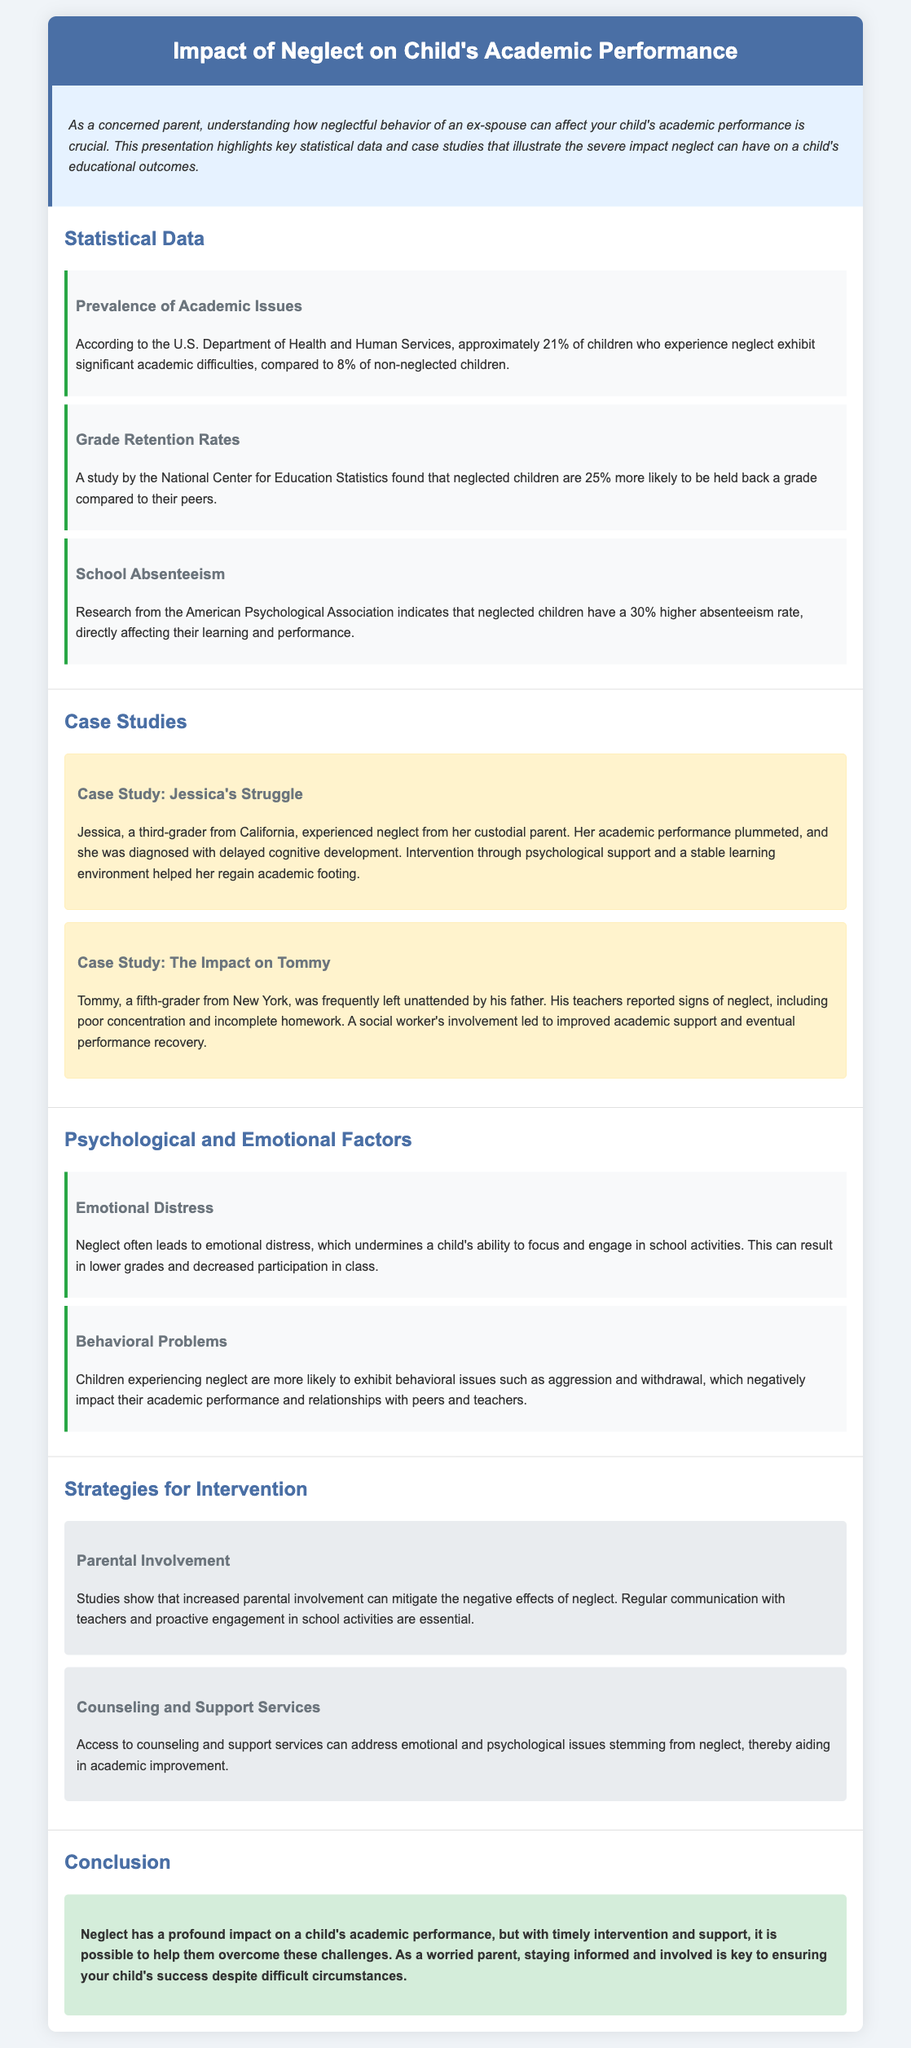what percentage of neglected children experience academic difficulties? The document states that approximately 21% of children who experience neglect exhibit significant academic difficulties.
Answer: 21% what is the increased likelihood of neglected children being held back a grade? The document indicates that neglected children are 25% more likely to be held back a grade compared to their peers.
Answer: 25% who conducted the research on school absenteeism of neglected children? According to the document, the American Psychological Association conducted the research on school absenteeism.
Answer: American Psychological Association what significant issue did Jessica experience due to neglect? The document mentions that Jessica's academic performance plummeted, and she was diagnosed with delayed cognitive development.
Answer: Delayed cognitive development what intervention helped Jessica regain her academic footing? The document states that intervention through psychological support and a stable learning environment helped Jessica regain her academic footing.
Answer: Psychological support why do neglected children have lower academic performance? The document highlights emotional distress and behavioral problems as reasons for lower academic performance in neglected children.
Answer: Emotional distress and behavioral problems what role does parental involvement play in mitigating neglect effects? The document asserts that studies show increased parental involvement can mitigate the negative effects of neglect.
Answer: Mitigate the negative effects of neglect what type of support can aid in academic improvement for neglected children? The document states that access to counseling and support services can address emotional and psychological issues, aiding in academic improvement.
Answer: Counseling and support services 